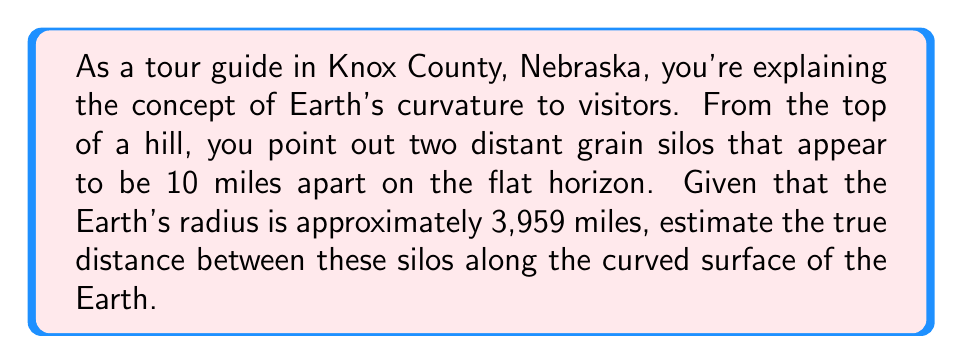Can you solve this math problem? To solve this problem, we'll use concepts from positively curved space geometry, specifically the geometry of a sphere (Earth). Here's a step-by-step approach:

1) First, we need to understand that the apparent distance (10 miles) is actually the length of a chord on the Earth's surface, while the true distance is the length of an arc.

2) Let's define our variables:
   $R$ = Earth's radius = 3,959 miles
   $d$ = apparent distance = 10 miles
   $\theta$ = central angle (in radians)
   $s$ = true distance (arc length)

3) We can use the chord length formula to find the central angle:
   $$d = 2R \sin(\frac{\theta}{2})$$

4) Rearranging this equation:
   $$\frac{\theta}{2} = \arcsin(\frac{d}{2R})$$

5) Substituting our values:
   $$\frac{\theta}{2} = \arcsin(\frac{10}{2 * 3959}) \approx 0.001263 \text{ radians}$$

6) Therefore, $\theta \approx 0.002526 \text{ radians}$

7) Now we can use the arc length formula:
   $$s = R\theta$$

8) Substituting our values:
   $$s = 3959 * 0.002526 \approx 10.0007 \text{ miles}$$

The difference between the apparent distance and the true distance is small due to the Earth's large radius compared to the distance we're measuring. However, this difference becomes more significant over larger distances.
Answer: 10.0007 miles 